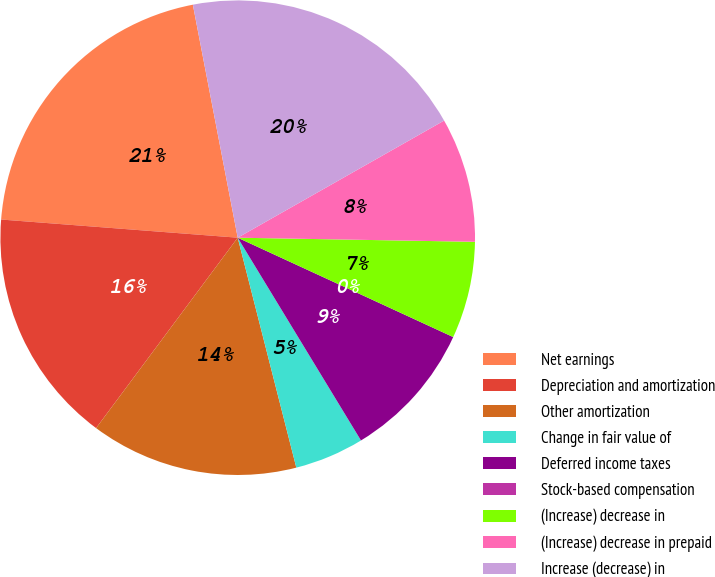Convert chart to OTSL. <chart><loc_0><loc_0><loc_500><loc_500><pie_chart><fcel>Net earnings<fcel>Depreciation and amortization<fcel>Other amortization<fcel>Change in fair value of<fcel>Deferred income taxes<fcel>Stock-based compensation<fcel>(Increase) decrease in<fcel>(Increase) decrease in prepaid<fcel>Increase (decrease) in<nl><fcel>20.75%<fcel>16.04%<fcel>14.15%<fcel>4.72%<fcel>9.43%<fcel>0.0%<fcel>6.6%<fcel>8.49%<fcel>19.81%<nl></chart> 